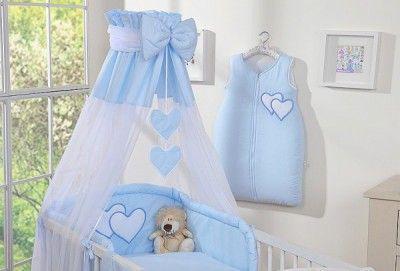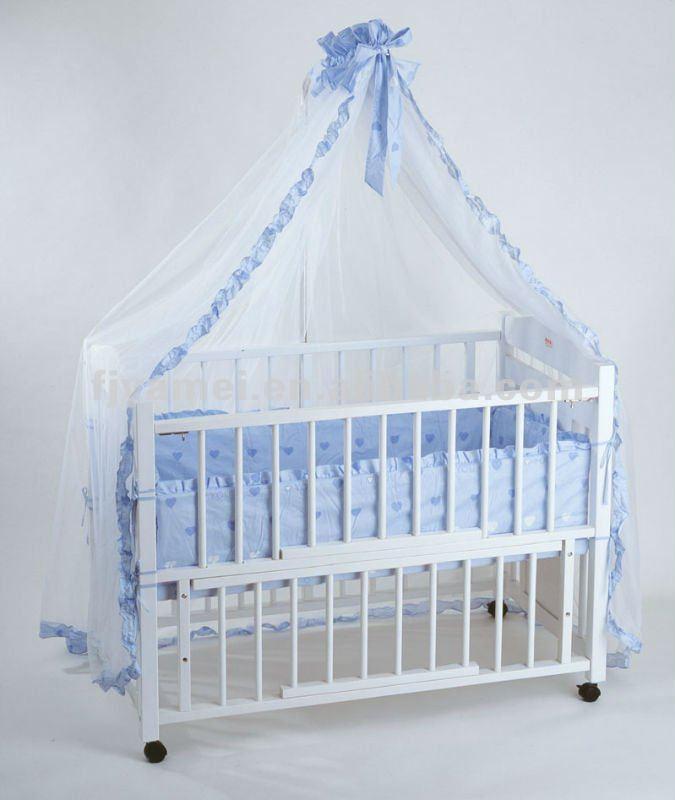The first image is the image on the left, the second image is the image on the right. For the images shown, is this caption "There is a stuffed animal in the left image." true? Answer yes or no. Yes. 